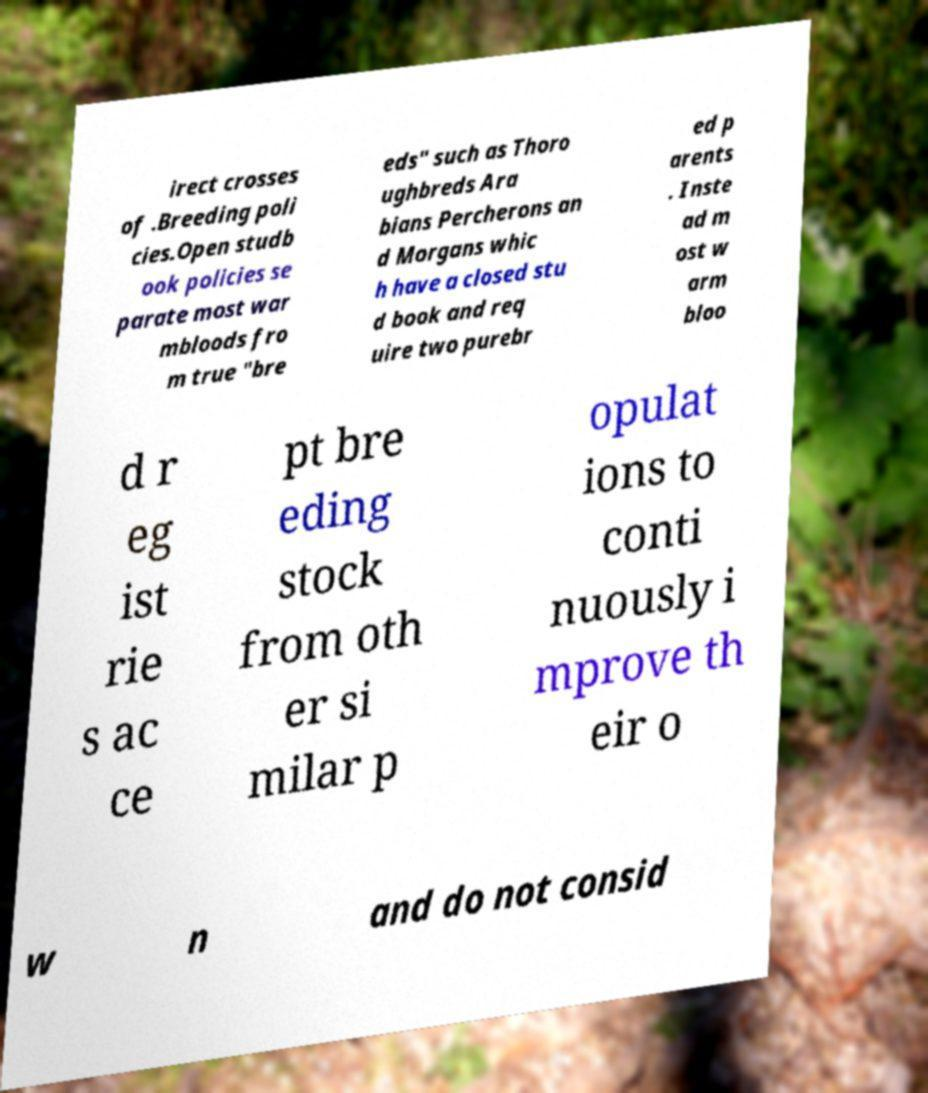What messages or text are displayed in this image? I need them in a readable, typed format. irect crosses of .Breeding poli cies.Open studb ook policies se parate most war mbloods fro m true "bre eds" such as Thoro ughbreds Ara bians Percherons an d Morgans whic h have a closed stu d book and req uire two purebr ed p arents . Inste ad m ost w arm bloo d r eg ist rie s ac ce pt bre eding stock from oth er si milar p opulat ions to conti nuously i mprove th eir o w n and do not consid 